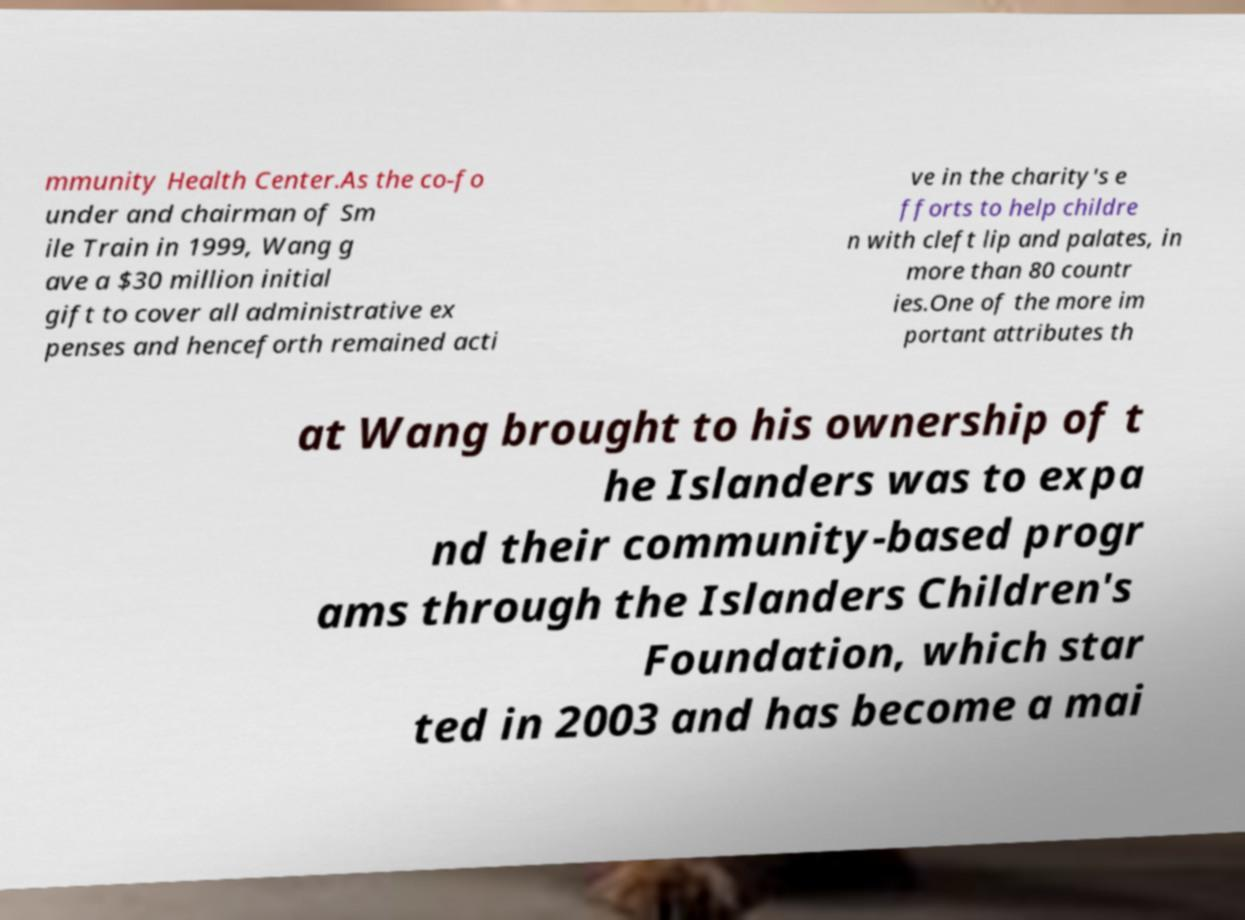Could you extract and type out the text from this image? mmunity Health Center.As the co-fo under and chairman of Sm ile Train in 1999, Wang g ave a $30 million initial gift to cover all administrative ex penses and henceforth remained acti ve in the charity's e fforts to help childre n with cleft lip and palates, in more than 80 countr ies.One of the more im portant attributes th at Wang brought to his ownership of t he Islanders was to expa nd their community-based progr ams through the Islanders Children's Foundation, which star ted in 2003 and has become a mai 